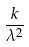Convert formula to latex. <formula><loc_0><loc_0><loc_500><loc_500>\frac { k } { \lambda ^ { 2 } }</formula> 